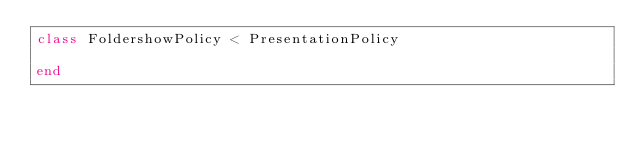Convert code to text. <code><loc_0><loc_0><loc_500><loc_500><_Ruby_>class FoldershowPolicy < PresentationPolicy

end
</code> 